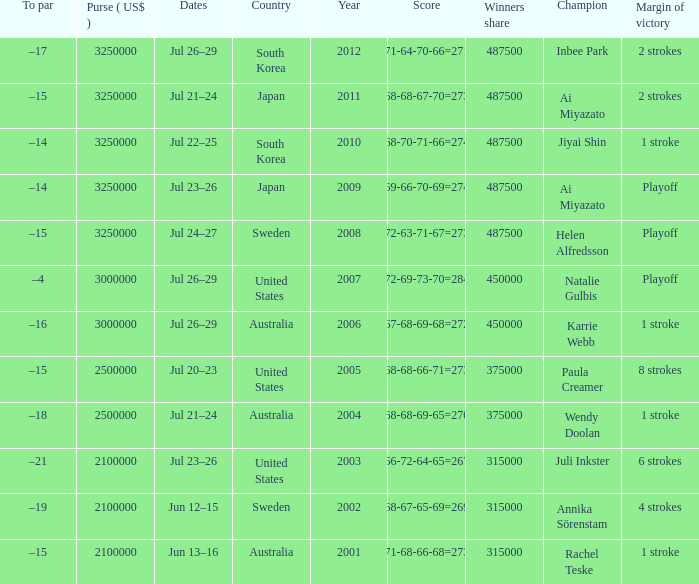How many years was Jiyai Shin the champion? 1.0. 